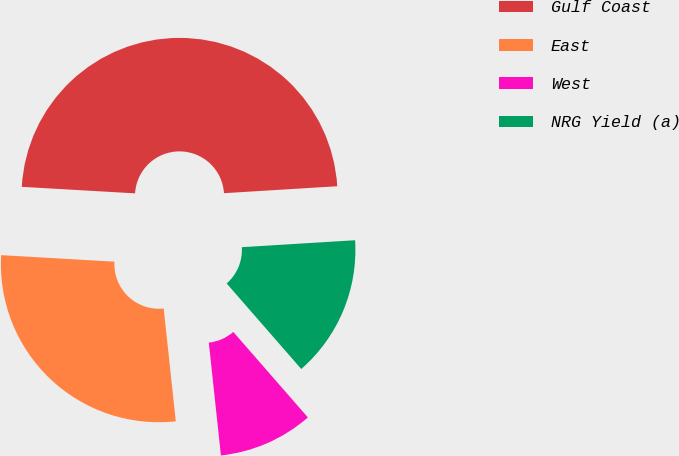Convert chart to OTSL. <chart><loc_0><loc_0><loc_500><loc_500><pie_chart><fcel>Gulf Coast<fcel>East<fcel>West<fcel>NRG Yield (a)<nl><fcel>48.11%<fcel>27.62%<fcel>9.71%<fcel>14.56%<nl></chart> 